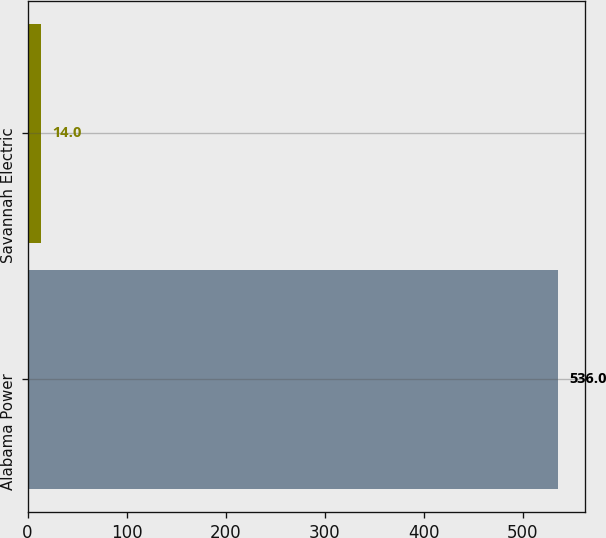Convert chart. <chart><loc_0><loc_0><loc_500><loc_500><bar_chart><fcel>Alabama Power<fcel>Savannah Electric<nl><fcel>536<fcel>14<nl></chart> 